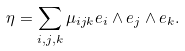<formula> <loc_0><loc_0><loc_500><loc_500>\eta = \sum _ { i , j , k } \mu _ { i j k } e _ { i } \wedge e _ { j } \wedge e _ { k } .</formula> 